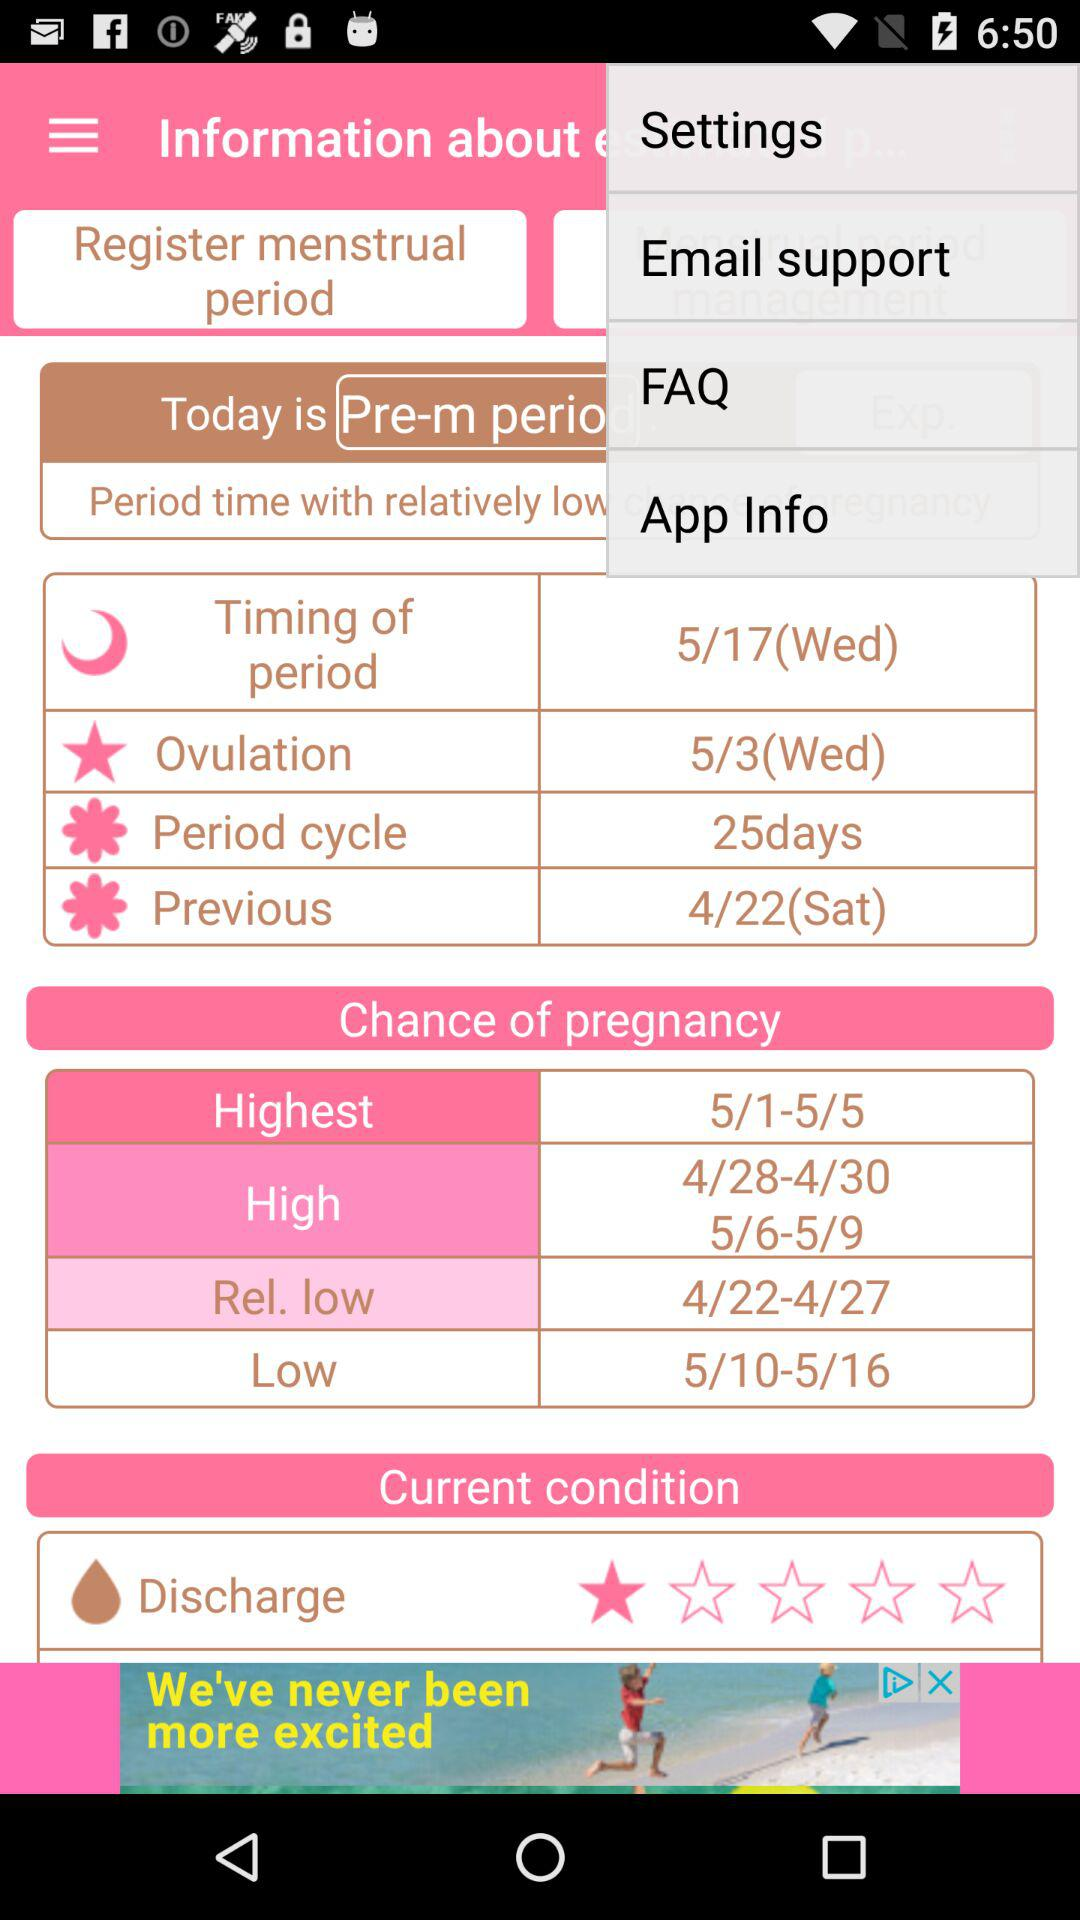On what date are the chances of pregnancy low? The chances of pregnancy are low from May 10 to May 16. 